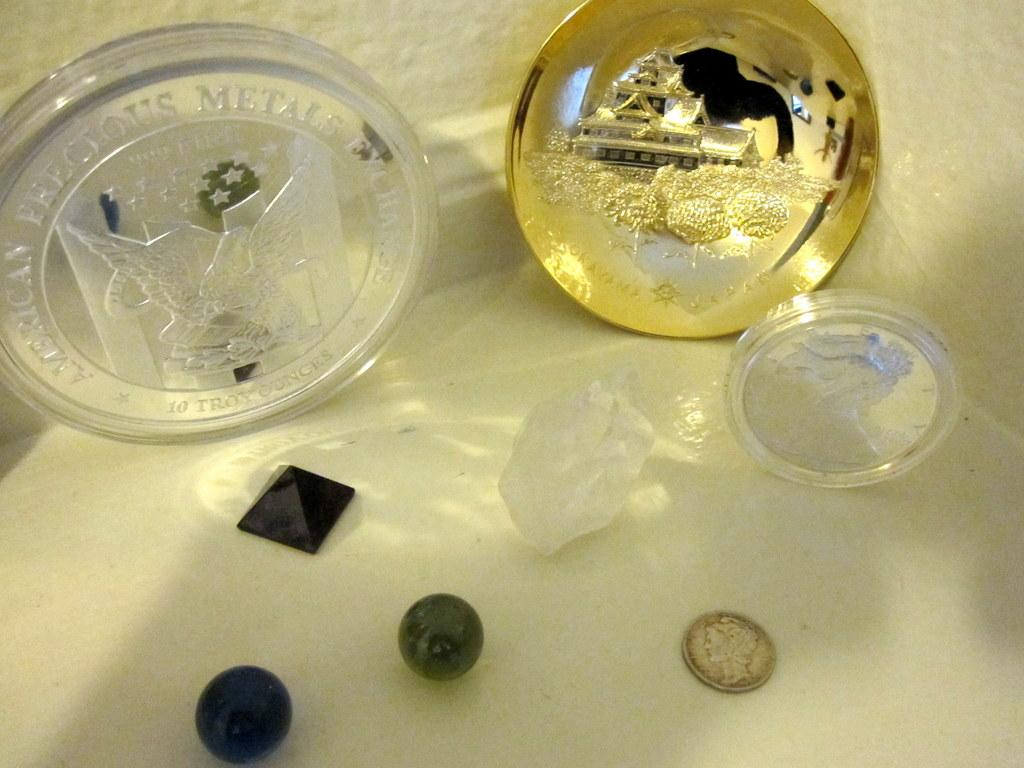Provide a one-sentence caption for the provided image. An American Precious Metals exchange plaque is shown with other trinquets. 